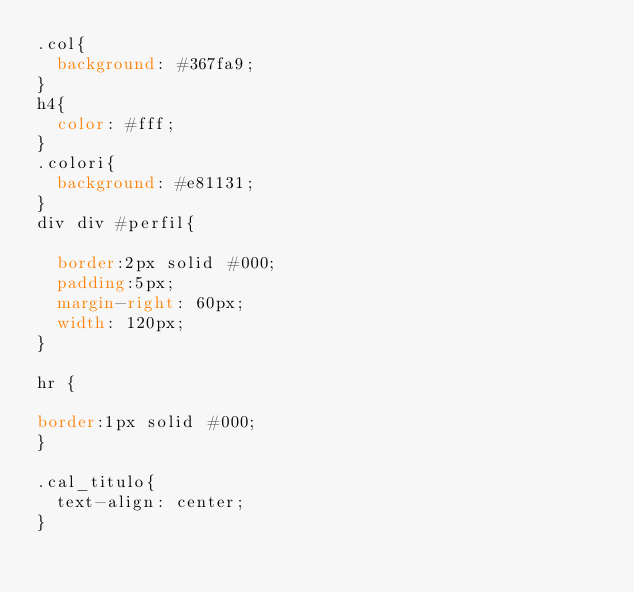<code> <loc_0><loc_0><loc_500><loc_500><_CSS_>.col{
	background: #367fa9;
}
h4{
	color: #fff;
}
.colori{
	background: #e81131;
}
div div #perfil{

	border:2px solid #000; 
	padding:5px; 
	margin-right: 60px;
	width: 120px;
} 

hr {

border:1px solid #000; 
}

.cal_titulo{
	text-align: center;
}</code> 